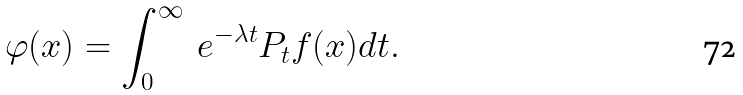<formula> <loc_0><loc_0><loc_500><loc_500>\varphi ( x ) = \int _ { 0 } ^ { \infty } \ e ^ { - \lambda t } P _ { t } f ( x ) d t .</formula> 